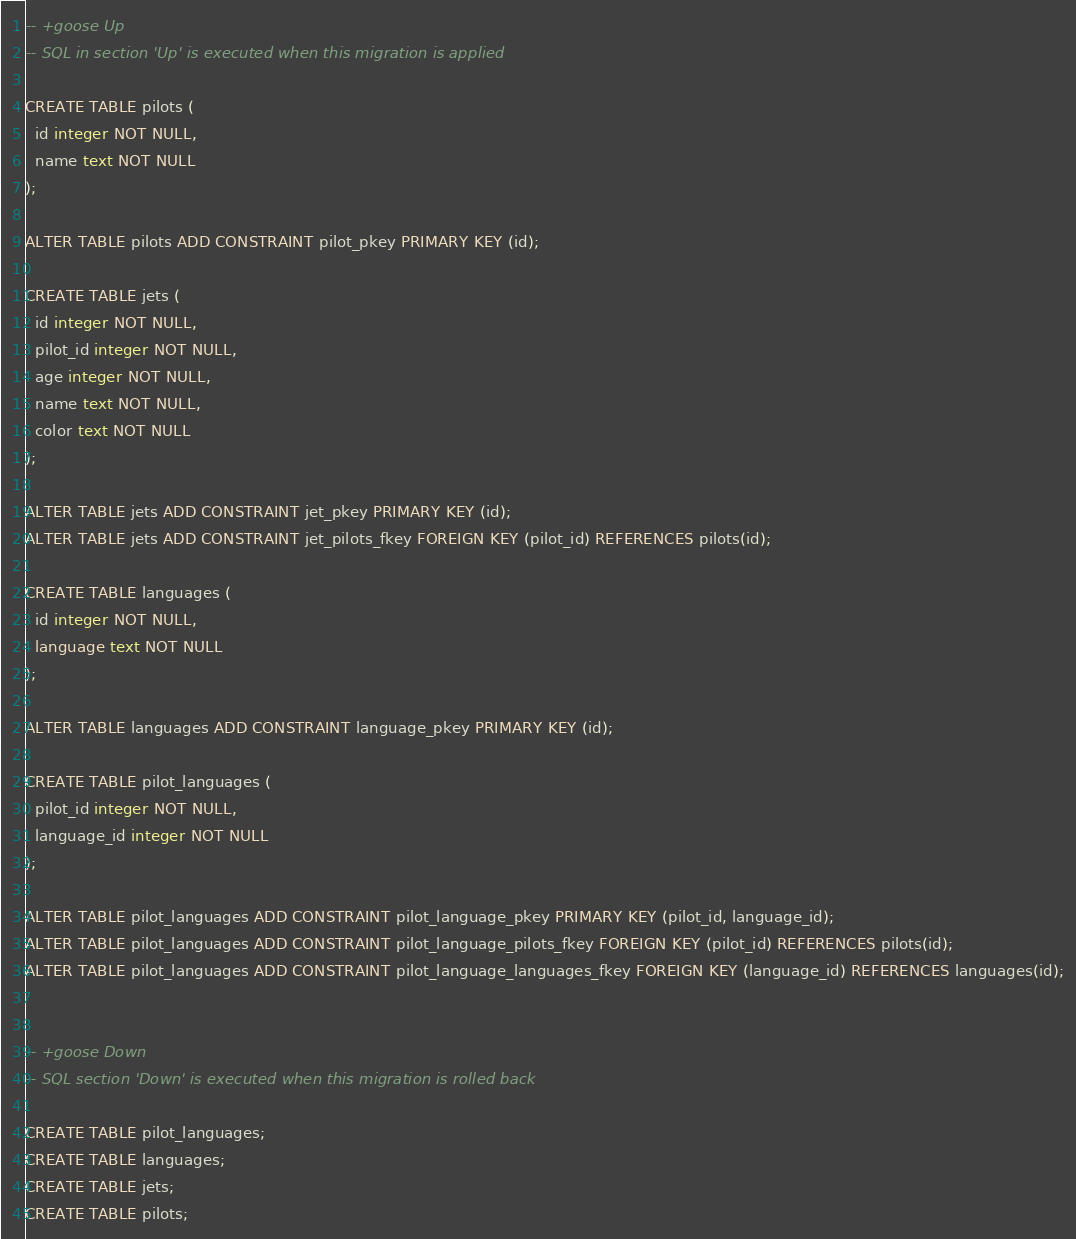Convert code to text. <code><loc_0><loc_0><loc_500><loc_500><_SQL_>
-- +goose Up
-- SQL in section 'Up' is executed when this migration is applied

CREATE TABLE pilots (
  id integer NOT NULL,
  name text NOT NULL
);

ALTER TABLE pilots ADD CONSTRAINT pilot_pkey PRIMARY KEY (id);

CREATE TABLE jets (
  id integer NOT NULL,
  pilot_id integer NOT NULL,
  age integer NOT NULL,
  name text NOT NULL,
  color text NOT NULL
);

ALTER TABLE jets ADD CONSTRAINT jet_pkey PRIMARY KEY (id);
ALTER TABLE jets ADD CONSTRAINT jet_pilots_fkey FOREIGN KEY (pilot_id) REFERENCES pilots(id);

CREATE TABLE languages (
  id integer NOT NULL,
  language text NOT NULL
);

ALTER TABLE languages ADD CONSTRAINT language_pkey PRIMARY KEY (id);

CREATE TABLE pilot_languages (
  pilot_id integer NOT NULL,
  language_id integer NOT NULL
);

ALTER TABLE pilot_languages ADD CONSTRAINT pilot_language_pkey PRIMARY KEY (pilot_id, language_id);
ALTER TABLE pilot_languages ADD CONSTRAINT pilot_language_pilots_fkey FOREIGN KEY (pilot_id) REFERENCES pilots(id);
ALTER TABLE pilot_languages ADD CONSTRAINT pilot_language_languages_fkey FOREIGN KEY (language_id) REFERENCES languages(id);


-- +goose Down
-- SQL section 'Down' is executed when this migration is rolled back

CREATE TABLE pilot_languages;
CREATE TABLE languages;
CREATE TABLE jets;
CREATE TABLE pilots;
</code> 